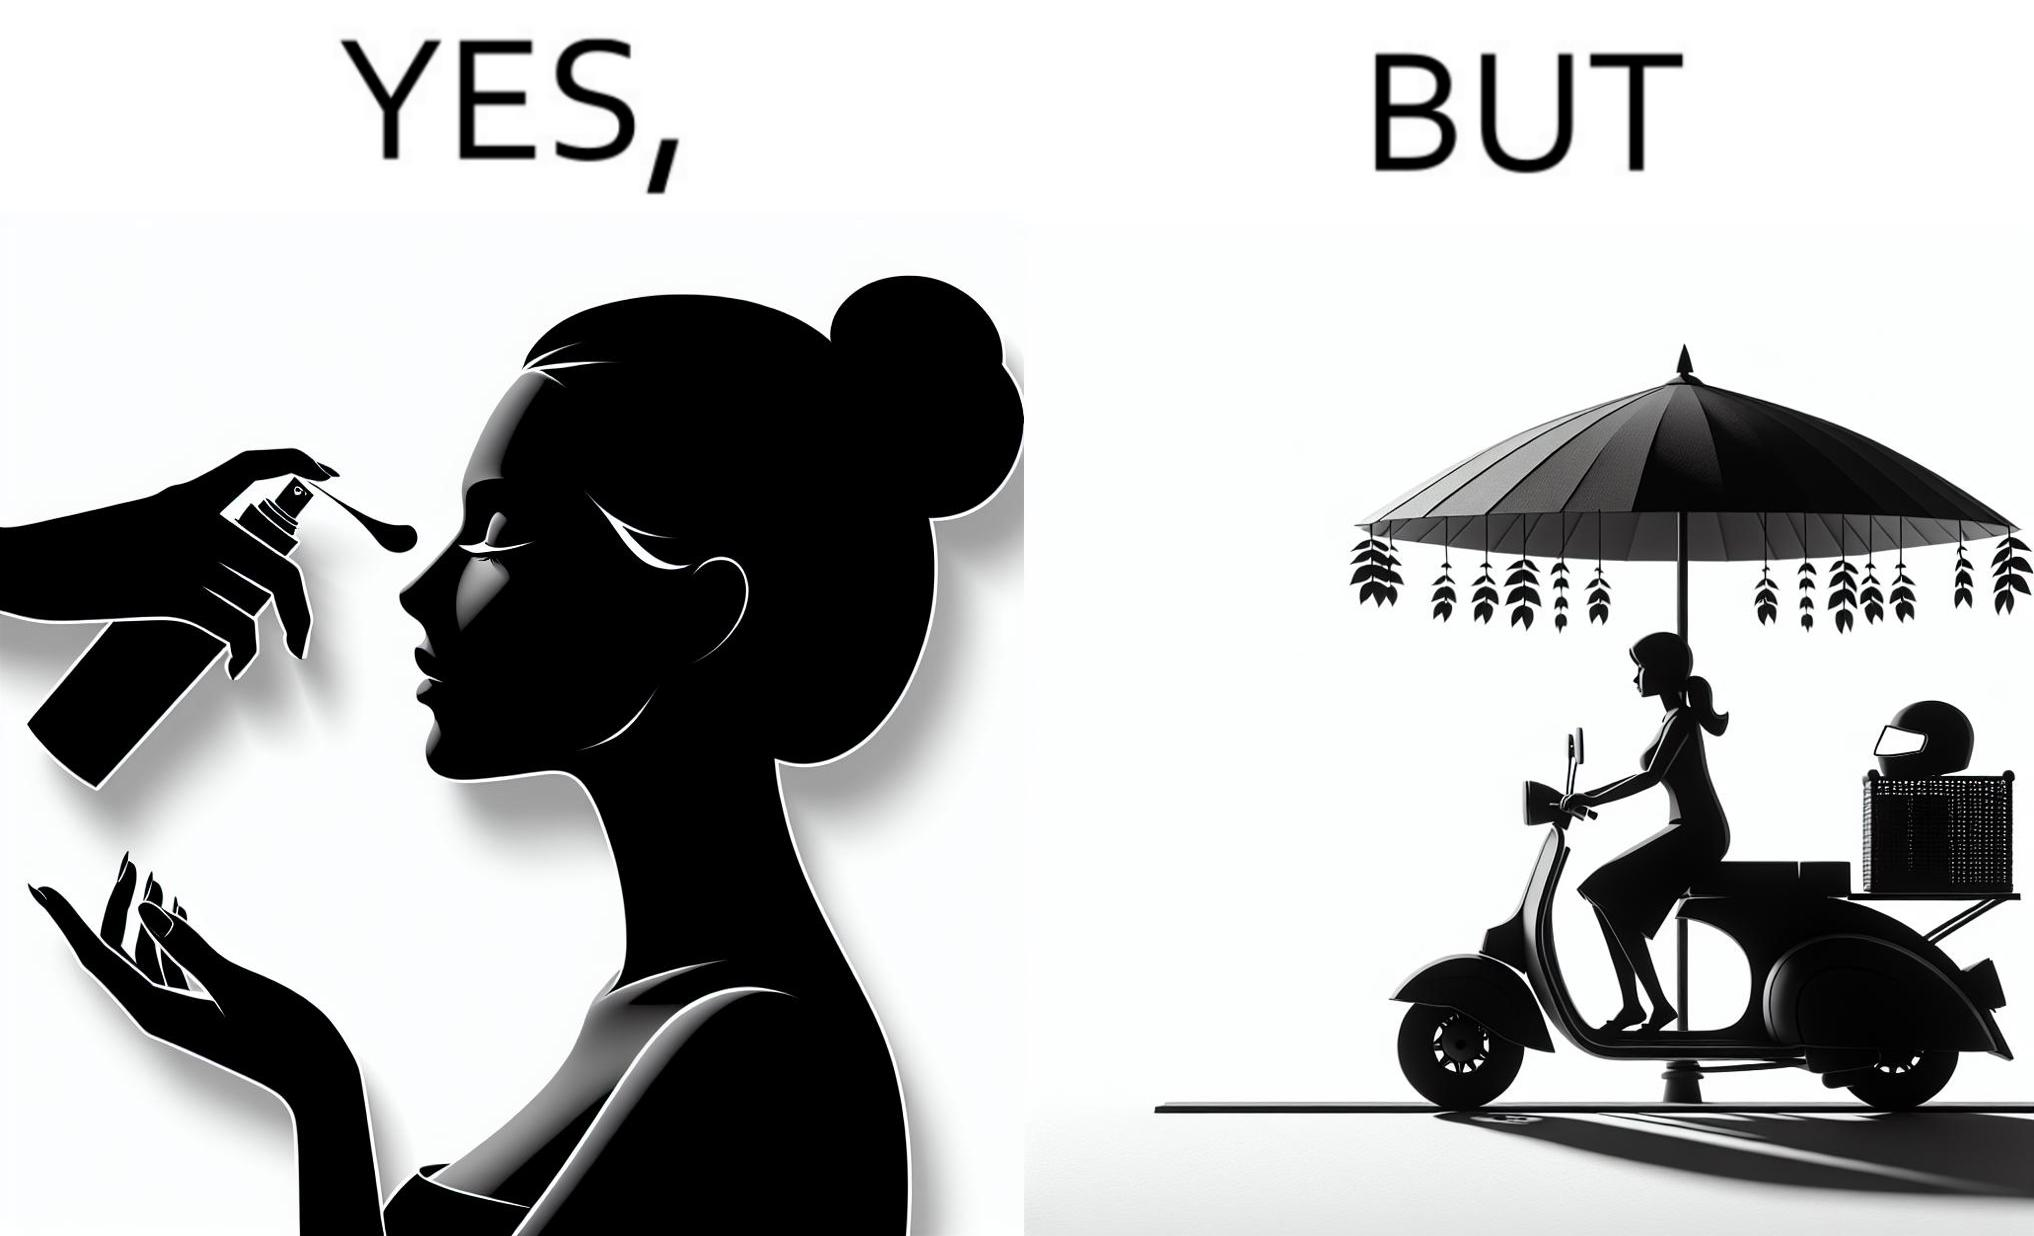Describe the content of this image. The image is funny because while the woman is concerned about protection from the sun rays, she is not concerned about her safety while riding a scooter. 